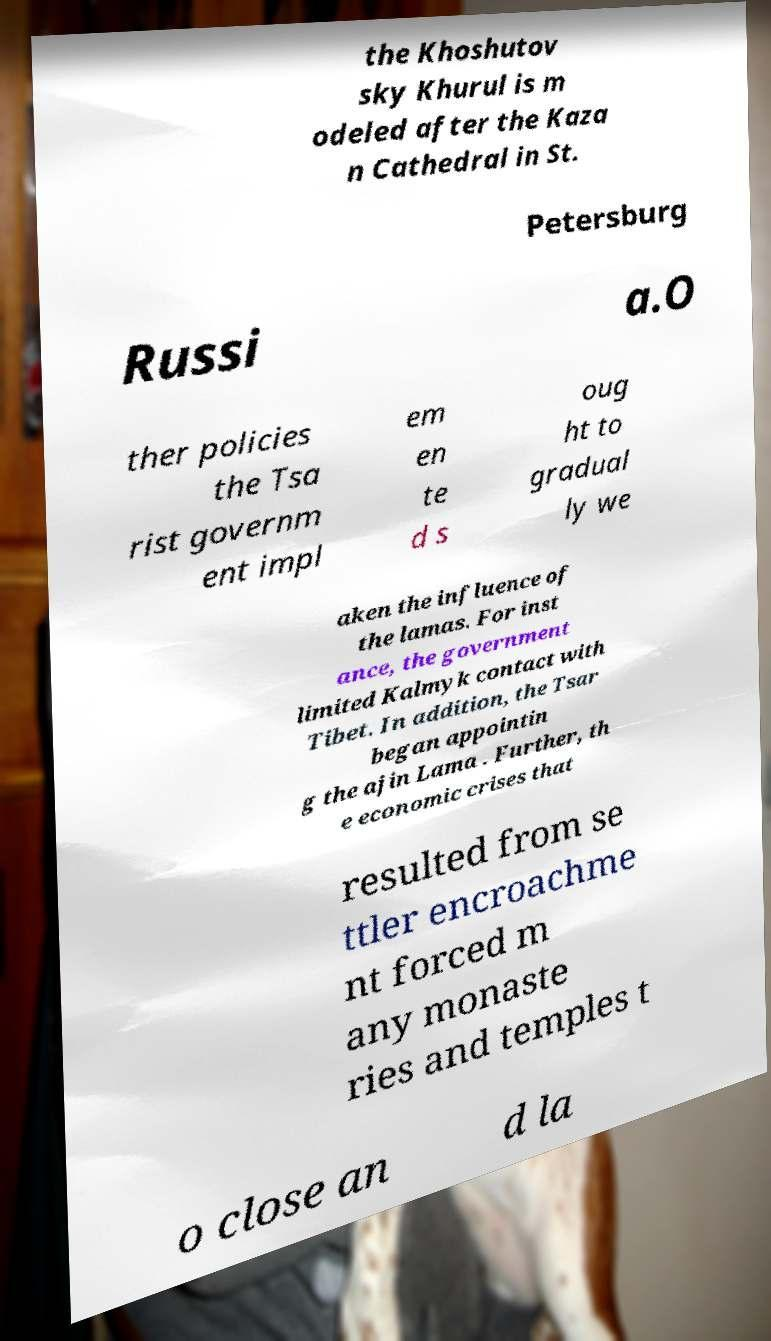I need the written content from this picture converted into text. Can you do that? the Khoshutov sky Khurul is m odeled after the Kaza n Cathedral in St. Petersburg Russi a.O ther policies the Tsa rist governm ent impl em en te d s oug ht to gradual ly we aken the influence of the lamas. For inst ance, the government limited Kalmyk contact with Tibet. In addition, the Tsar began appointin g the ajin Lama . Further, th e economic crises that resulted from se ttler encroachme nt forced m any monaste ries and temples t o close an d la 